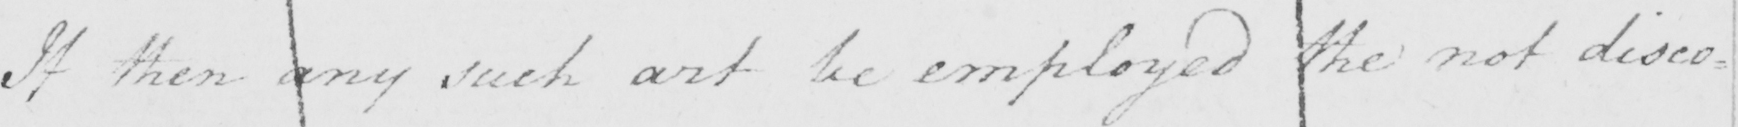Please transcribe the handwritten text in this image. If then any such art be employed the not disco= 